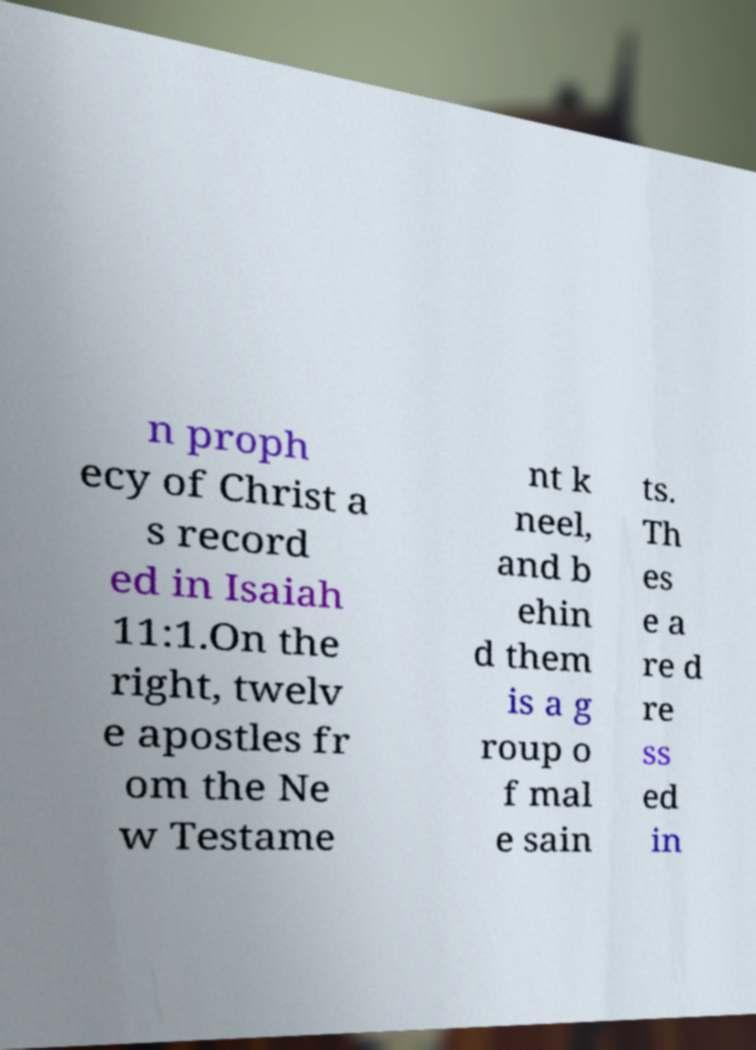Could you extract and type out the text from this image? n proph ecy of Christ a s record ed in Isaiah 11:1.On the right, twelv e apostles fr om the Ne w Testame nt k neel, and b ehin d them is a g roup o f mal e sain ts. Th es e a re d re ss ed in 